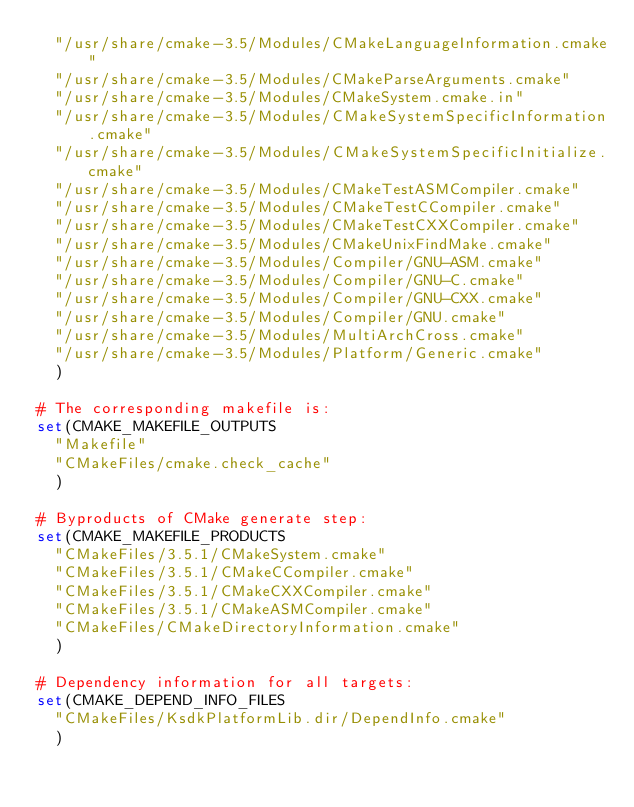<code> <loc_0><loc_0><loc_500><loc_500><_CMake_>  "/usr/share/cmake-3.5/Modules/CMakeLanguageInformation.cmake"
  "/usr/share/cmake-3.5/Modules/CMakeParseArguments.cmake"
  "/usr/share/cmake-3.5/Modules/CMakeSystem.cmake.in"
  "/usr/share/cmake-3.5/Modules/CMakeSystemSpecificInformation.cmake"
  "/usr/share/cmake-3.5/Modules/CMakeSystemSpecificInitialize.cmake"
  "/usr/share/cmake-3.5/Modules/CMakeTestASMCompiler.cmake"
  "/usr/share/cmake-3.5/Modules/CMakeTestCCompiler.cmake"
  "/usr/share/cmake-3.5/Modules/CMakeTestCXXCompiler.cmake"
  "/usr/share/cmake-3.5/Modules/CMakeUnixFindMake.cmake"
  "/usr/share/cmake-3.5/Modules/Compiler/GNU-ASM.cmake"
  "/usr/share/cmake-3.5/Modules/Compiler/GNU-C.cmake"
  "/usr/share/cmake-3.5/Modules/Compiler/GNU-CXX.cmake"
  "/usr/share/cmake-3.5/Modules/Compiler/GNU.cmake"
  "/usr/share/cmake-3.5/Modules/MultiArchCross.cmake"
  "/usr/share/cmake-3.5/Modules/Platform/Generic.cmake"
  )

# The corresponding makefile is:
set(CMAKE_MAKEFILE_OUTPUTS
  "Makefile"
  "CMakeFiles/cmake.check_cache"
  )

# Byproducts of CMake generate step:
set(CMAKE_MAKEFILE_PRODUCTS
  "CMakeFiles/3.5.1/CMakeSystem.cmake"
  "CMakeFiles/3.5.1/CMakeCCompiler.cmake"
  "CMakeFiles/3.5.1/CMakeCXXCompiler.cmake"
  "CMakeFiles/3.5.1/CMakeASMCompiler.cmake"
  "CMakeFiles/CMakeDirectoryInformation.cmake"
  )

# Dependency information for all targets:
set(CMAKE_DEPEND_INFO_FILES
  "CMakeFiles/KsdkPlatformLib.dir/DependInfo.cmake"
  )
</code> 